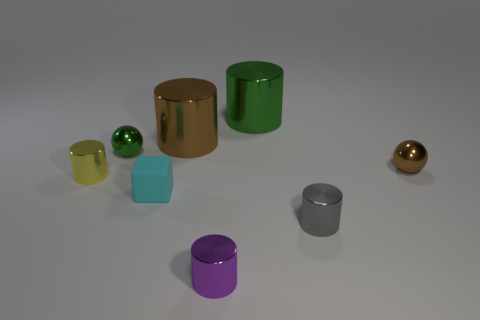Subtract all gray cylinders. How many cylinders are left? 4 Subtract all large green cylinders. How many cylinders are left? 4 Subtract all blue cylinders. Subtract all brown blocks. How many cylinders are left? 5 Add 2 cyan things. How many objects exist? 10 Subtract all blocks. How many objects are left? 7 Add 3 tiny blocks. How many tiny blocks are left? 4 Add 5 large yellow metallic balls. How many large yellow metallic balls exist? 5 Subtract 1 purple cylinders. How many objects are left? 7 Subtract all shiny things. Subtract all big brown metal things. How many objects are left? 0 